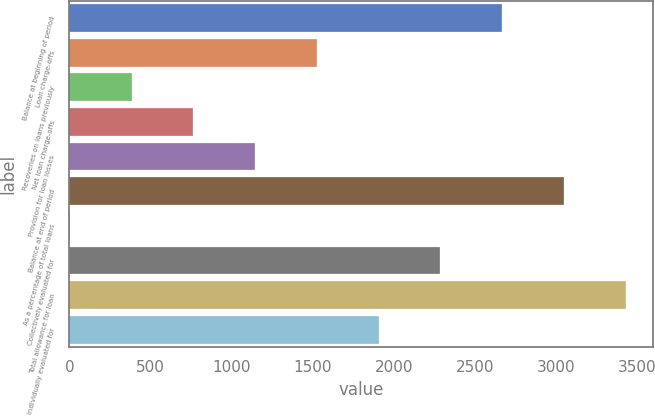Convert chart. <chart><loc_0><loc_0><loc_500><loc_500><bar_chart><fcel>Balance at beginning of period<fcel>Loan charge-offs<fcel>Recoveries on loans previously<fcel>Net loan charge-offs<fcel>Provision for loan losses<fcel>Balance at end of period<fcel>As a percentage of total loans<fcel>Collectively evaluated for<fcel>Total allowance for loan<fcel>Individually evaluated for<nl><fcel>2668.34<fcel>1525.64<fcel>382.94<fcel>763.84<fcel>1144.74<fcel>3049.24<fcel>2.04<fcel>2287.44<fcel>3430.14<fcel>1906.54<nl></chart> 